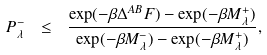<formula> <loc_0><loc_0><loc_500><loc_500>P ^ { - } _ { \lambda } \ \leq \ \frac { \exp ( - \beta \Delta ^ { A B } F ) - \exp ( - \beta M ^ { + } _ { \lambda } ) } { \exp ( - \beta M ^ { - } _ { \lambda } ) - \exp ( - \beta M ^ { + } _ { \lambda } ) } ,</formula> 